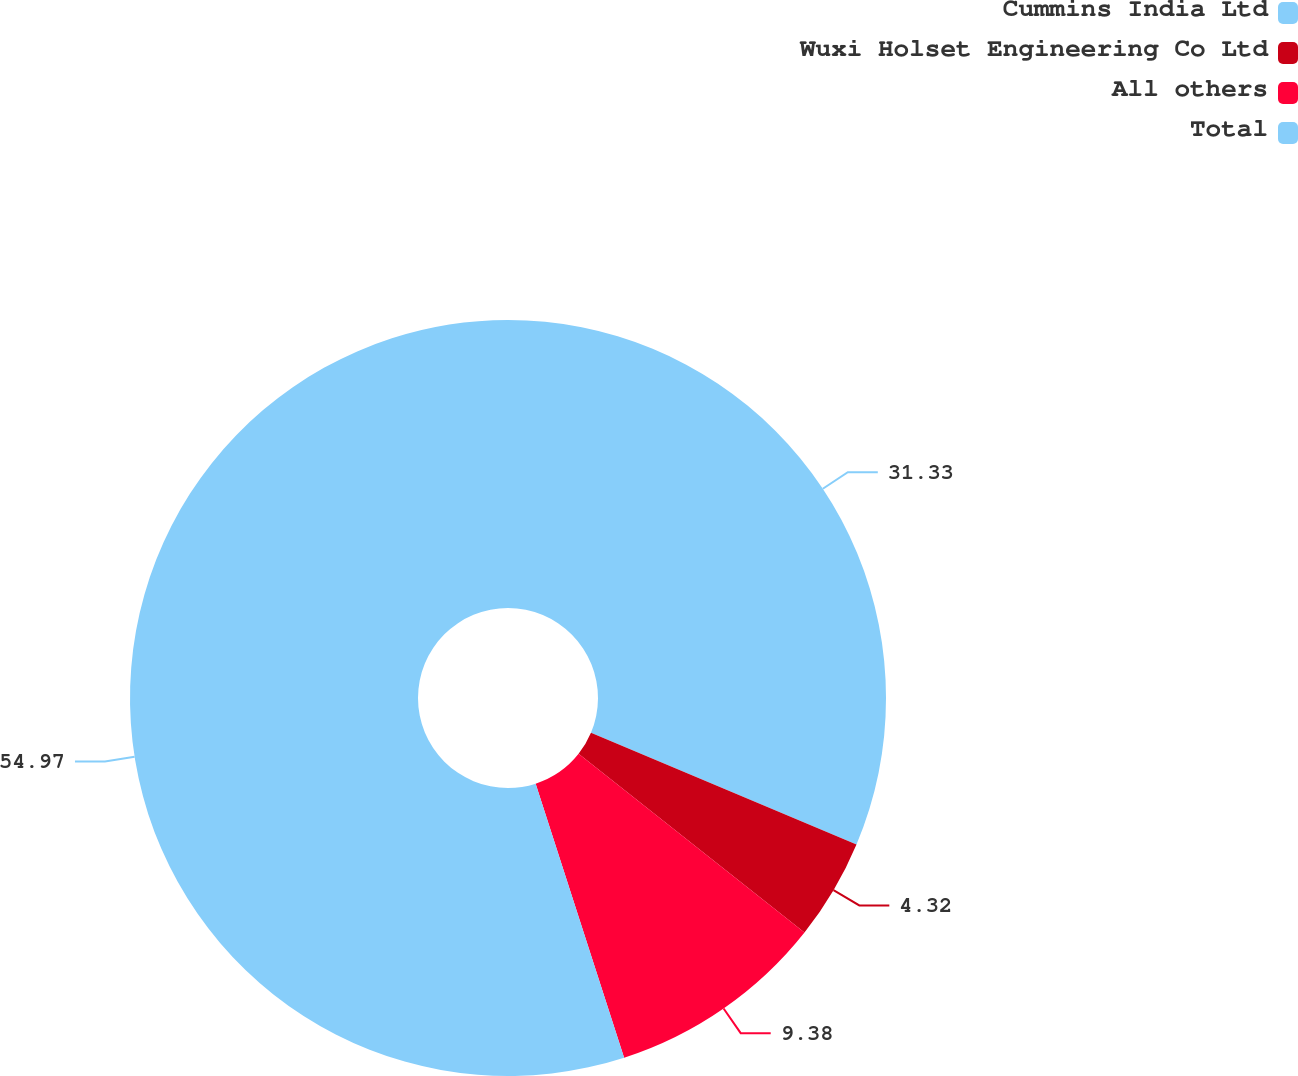Convert chart. <chart><loc_0><loc_0><loc_500><loc_500><pie_chart><fcel>Cummins India Ltd<fcel>Wuxi Holset Engineering Co Ltd<fcel>All others<fcel>Total<nl><fcel>31.33%<fcel>4.32%<fcel>9.38%<fcel>54.97%<nl></chart> 